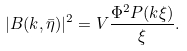Convert formula to latex. <formula><loc_0><loc_0><loc_500><loc_500>| B ( k , \bar { \eta } ) | ^ { 2 } = V \frac { \Phi ^ { 2 } P ( k \xi ) } { \xi } .</formula> 